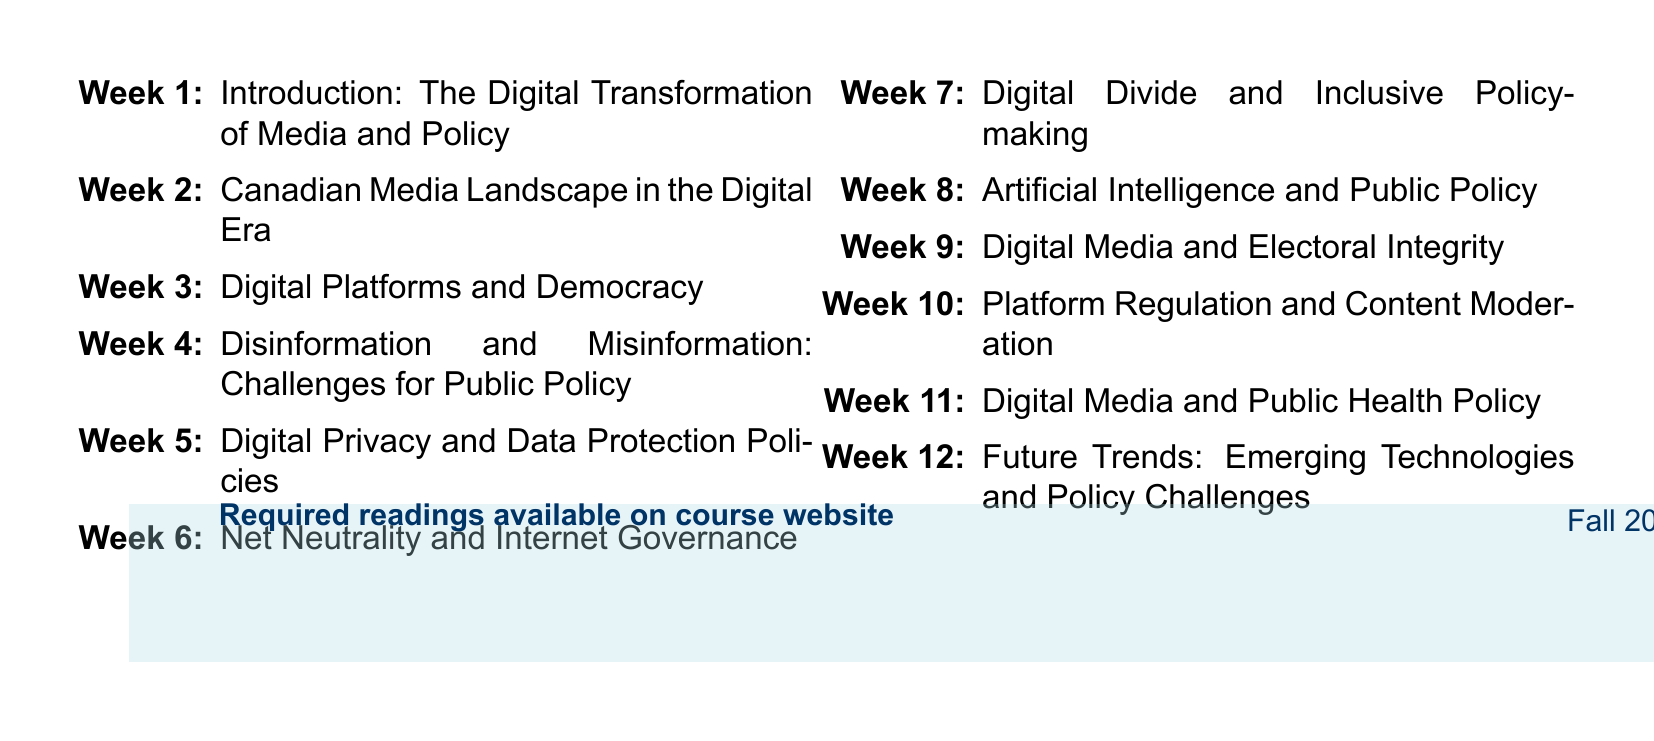What is the course title? The course title is indicated at the beginning of the document and is related to the main theme of the course.
Answer: Media and Public Policy in the Digital Age Who is the instructor? The instructor's name is provided in the header of the document.
Answer: Dr. Sarah Thompson How many weeks are there in the course? The total number of weeks is shown by the number of different weekly topics outlined in the agenda.
Answer: 12 What is the topic for week 4? The specific topic for each week is listed sequentially, making it easy to identify week 4's subject matter.
Answer: Disinformation and Misinformation: Challenges for Public Policy Which reading is required for week 6? Each week lists required readings that correspond to the weekly topics, enabling retrieval of specific reading titles.
Answer: Benkler, Y. (2016). 'Degrees of Freedom, Dimensions of Power' What is a key focus of week 8's topic? Each weekly topic encompasses broader themes within media and public policy, particularly regarding technology impacts.
Answer: Artificial Intelligence and Public Policy Which report is listed as required reading for week 11? Required readings for each week include reports and analyses relevant to the topics discussed, particularly for week 11.
Answer: Public Health Agency of Canada. (2020). 'Digital Public Health: An Overview of Health Canada's Approach to Digital Health Technologies' What essential concept is addressed in week 7? Each week’s topic is structured around pressing themes in media and policy, indicating significant societal issues to explore.
Answer: Digital Divide and Inclusive Policy-making What is the primary issue discussed in week 3? Identifying the topic for any week reveals the central issues and challenges associated with media and democracy in the digital context.
Answer: Digital Platforms and Democracy 